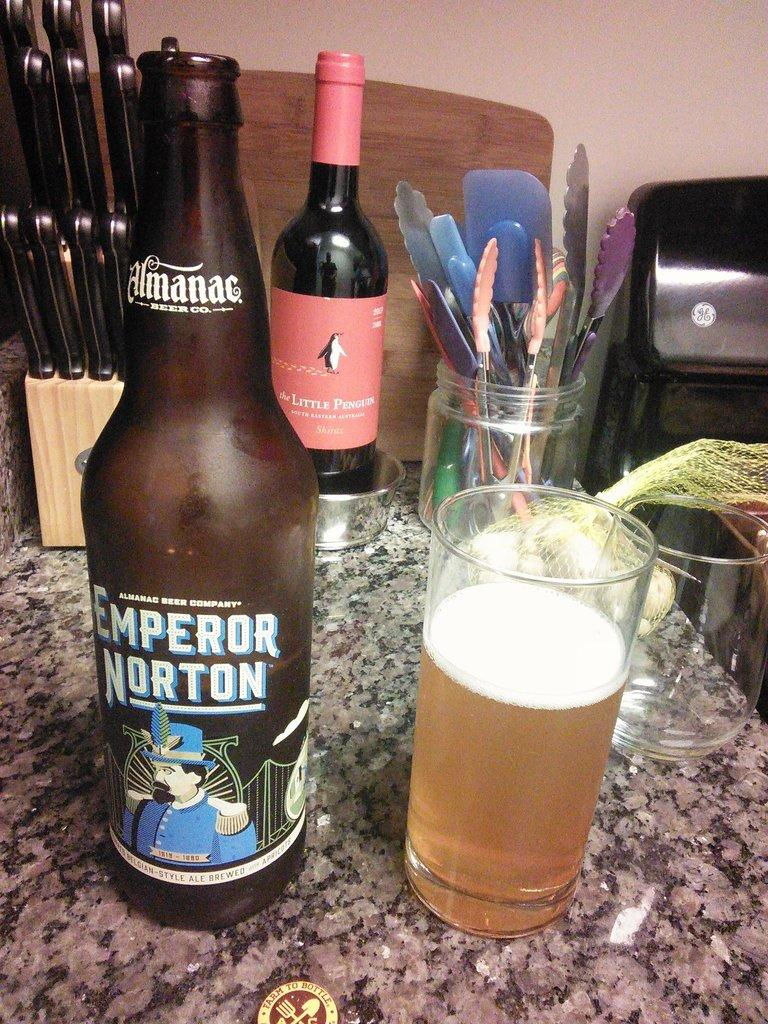<image>
Render a clear and concise summary of the photo. a bottle of Emperior Norton is sitting by a glass full of it 